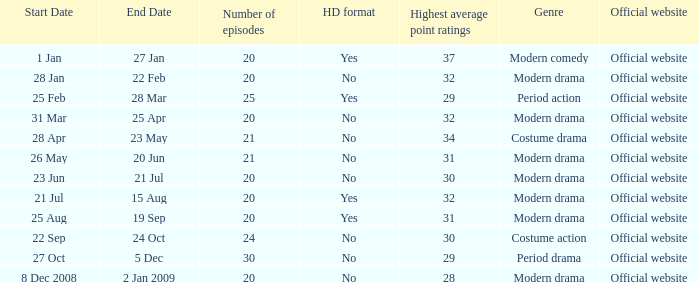What was the airing date when the number of episodes was larger than 20 and had the genre of costume action? 22 Sep- 24 Oct. 